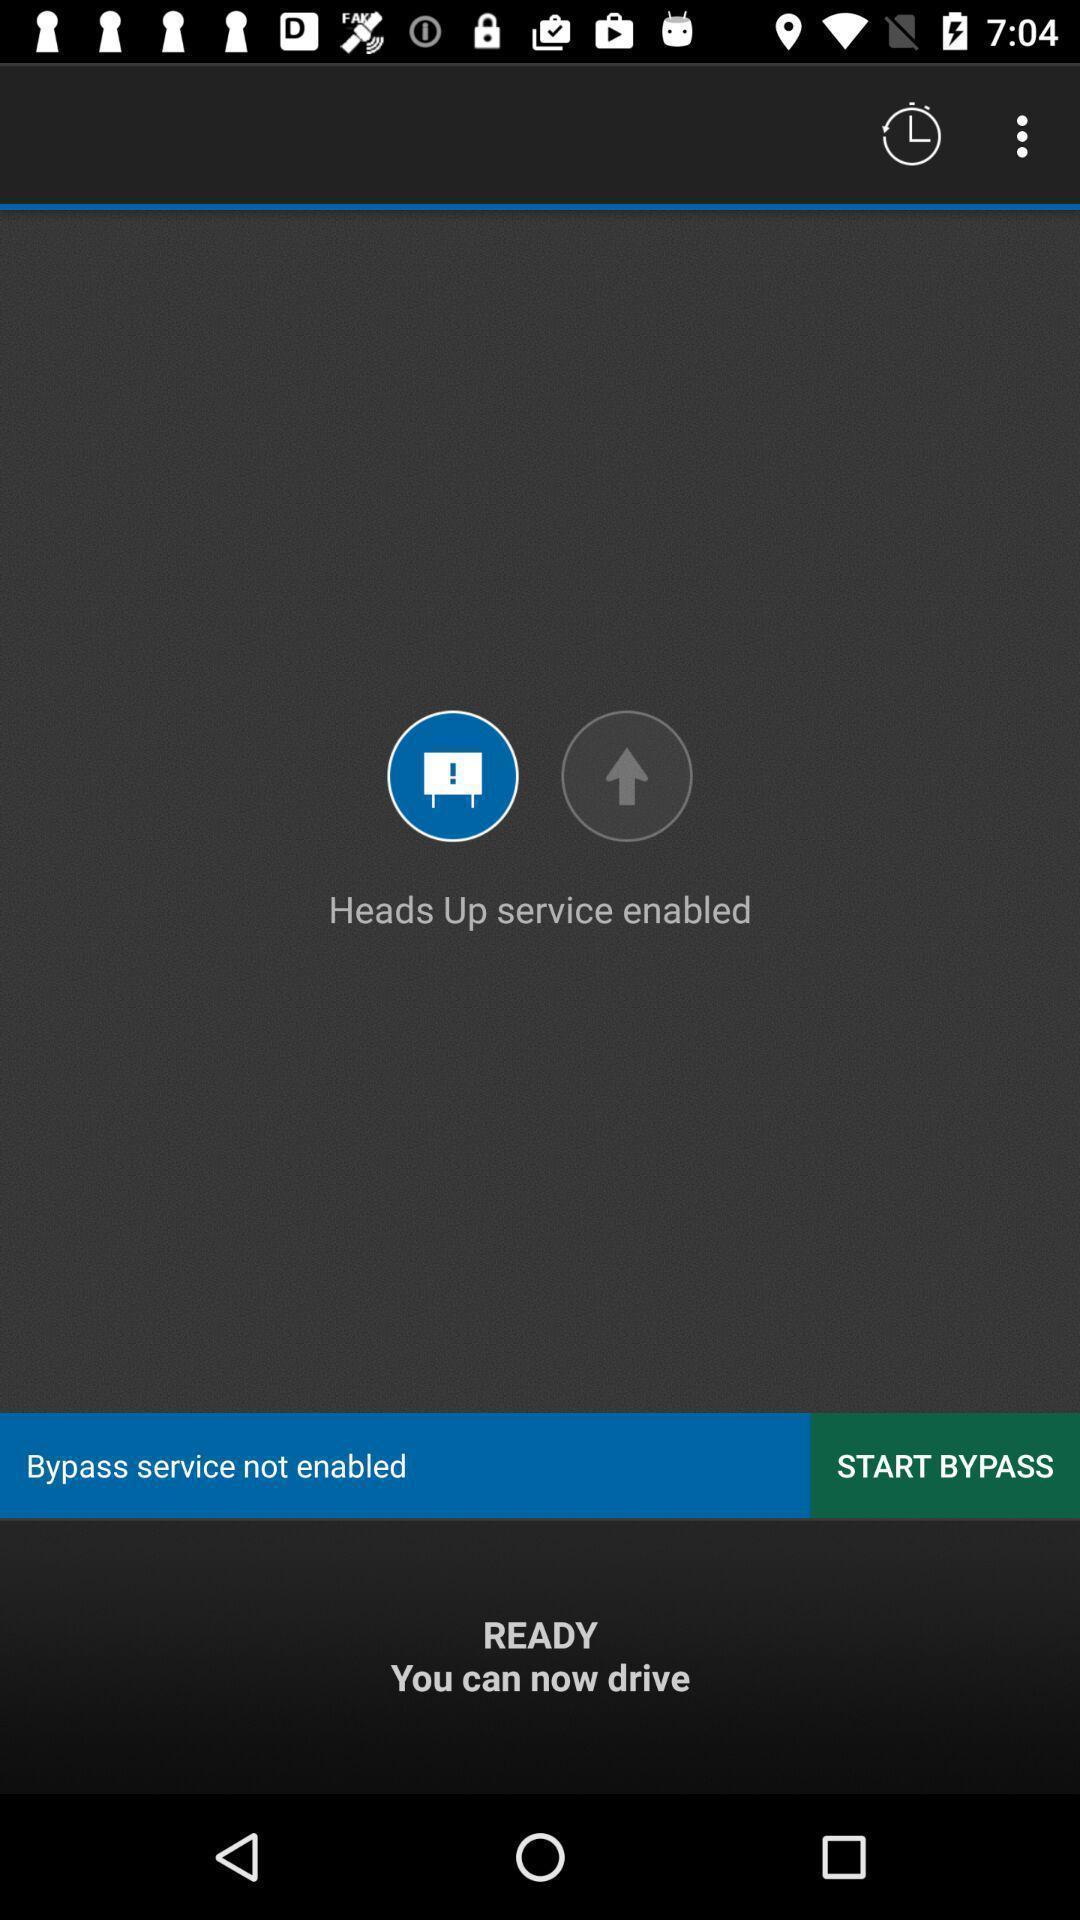Summarize the main components in this picture. Screen displaying the starting page. 